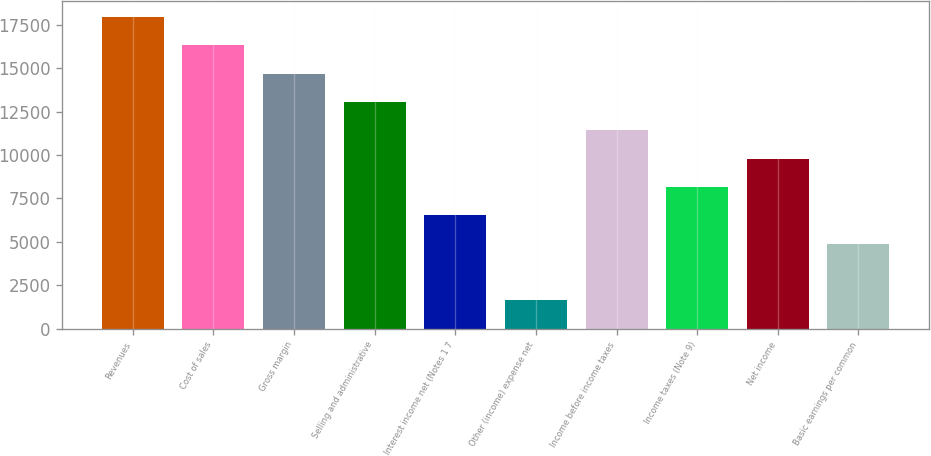Convert chart to OTSL. <chart><loc_0><loc_0><loc_500><loc_500><bar_chart><fcel>Revenues<fcel>Cost of sales<fcel>Gross margin<fcel>Selling and administrative<fcel>Interest income net (Notes 1 7<fcel>Other (income) expense net<fcel>Income before income taxes<fcel>Income taxes (Note 9)<fcel>Net income<fcel>Basic earnings per common<nl><fcel>17958.4<fcel>16325.9<fcel>14693.4<fcel>13060.9<fcel>6530.79<fcel>1633.23<fcel>11428.4<fcel>8163.31<fcel>9795.83<fcel>4898.27<nl></chart> 